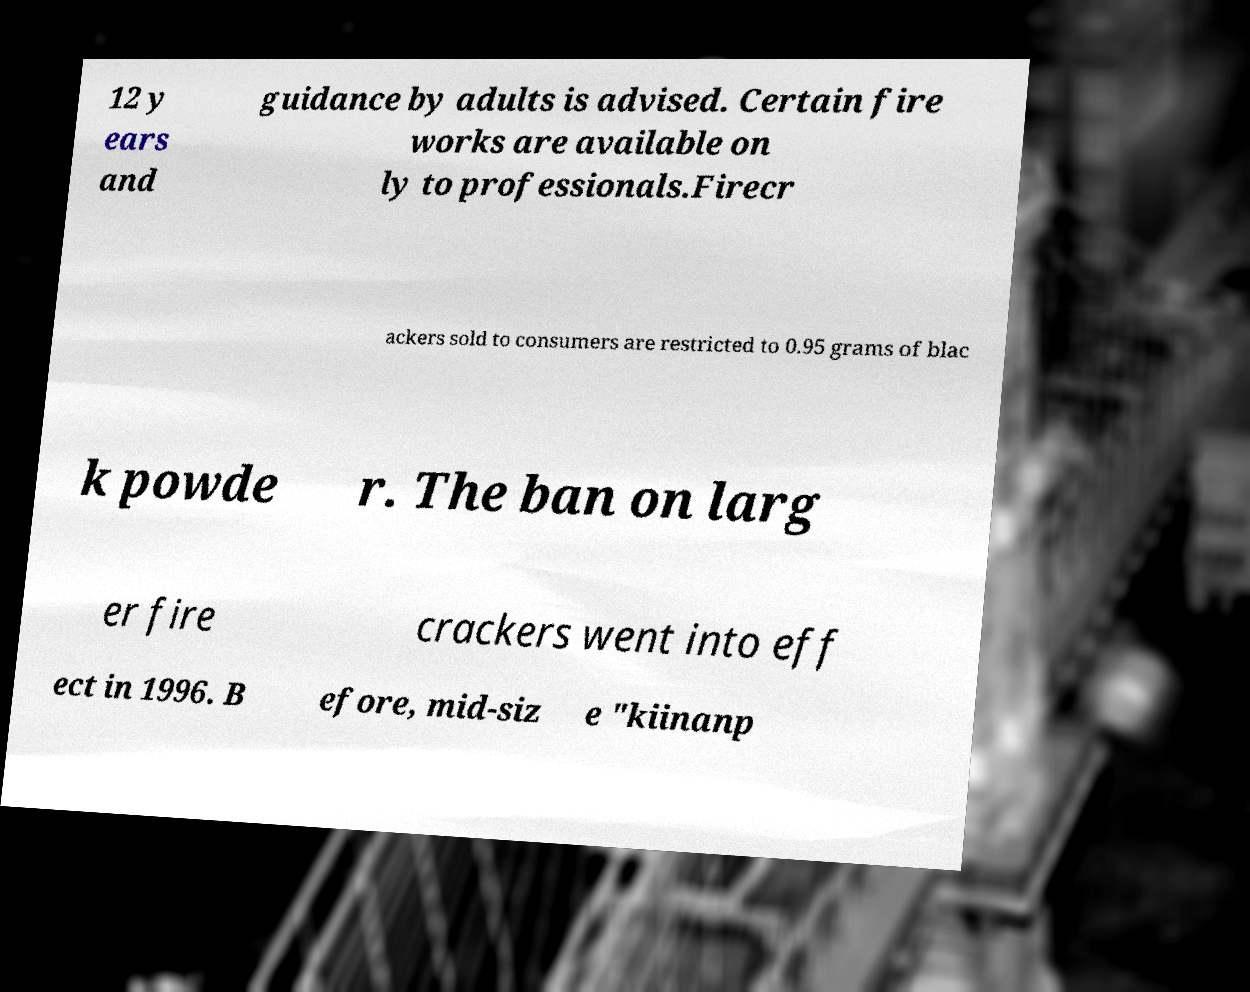Please read and relay the text visible in this image. What does it say? 12 y ears and guidance by adults is advised. Certain fire works are available on ly to professionals.Firecr ackers sold to consumers are restricted to 0.95 grams of blac k powde r. The ban on larg er fire crackers went into eff ect in 1996. B efore, mid-siz e "kiinanp 